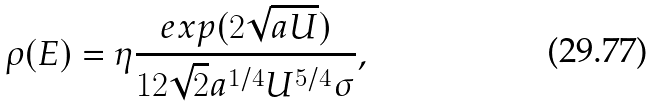<formula> <loc_0><loc_0><loc_500><loc_500>\rho ( E ) = \eta \frac { e x p ( 2 \sqrt { a U } ) } { 1 2 \sqrt { 2 } a ^ { 1 / 4 } U ^ { 5 / 4 } \sigma } ,</formula> 